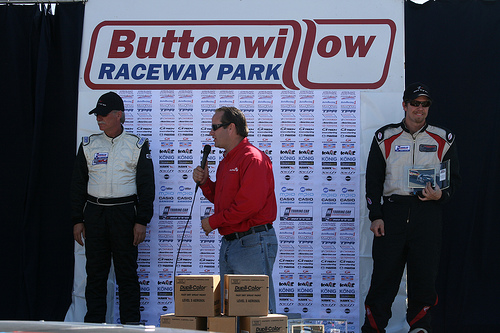<image>
Is there a red man to the left of the player? Yes. From this viewpoint, the red man is positioned to the left side relative to the player. 